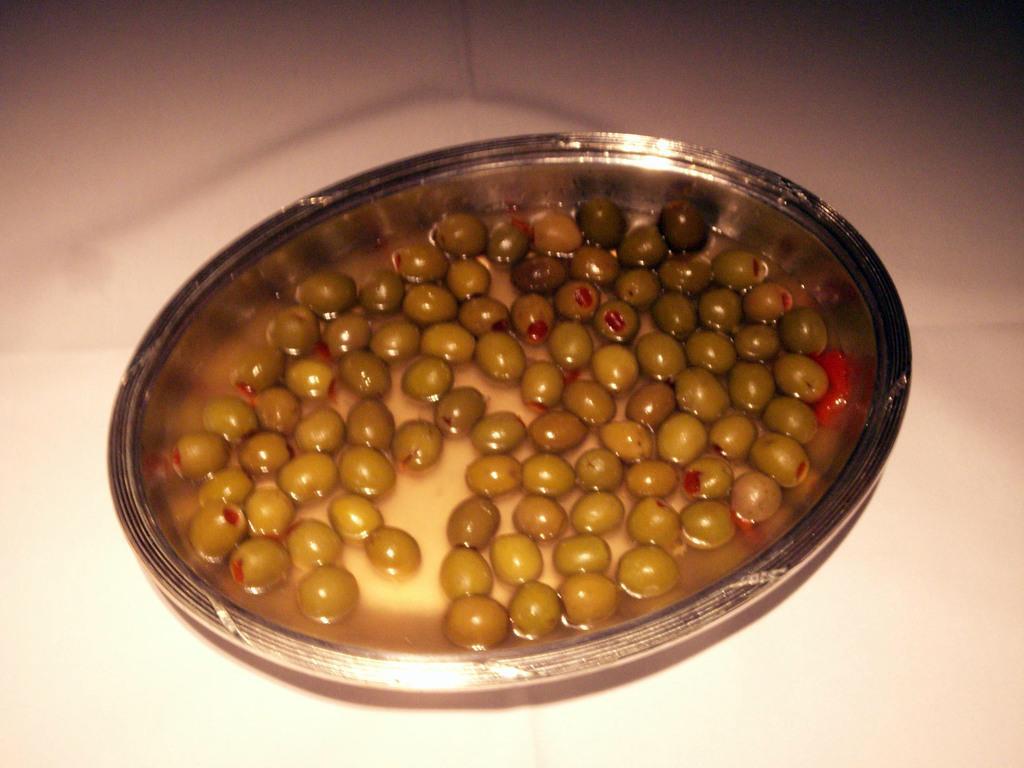Please provide a concise description of this image. In this image we can see some olives and water in a bowl which is placed on the surface. 